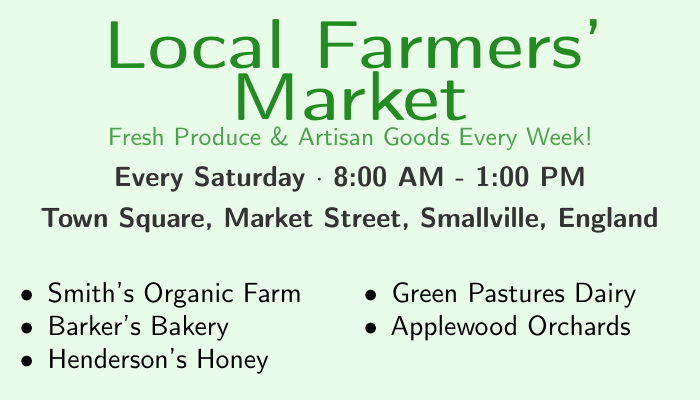What day is the farmers' market held? The document states that the farmers' market occurs every Saturday.
Answer: Saturday What are the opening hours of the market? The market operates from 8:00 AM to 1:00 PM.
Answer: 8:00 AM - 1:00 PM Where is the farmers' market located? The document specifies the location as Town Square, Market Street, Smallville, England.
Answer: Town Square, Market Street, Smallville, England Which vendor sells honey? The list of vendors includes Henderson's Honey as the honey seller.
Answer: Henderson's Honey How many key vendors are listed? There are five vendors mentioned in the document.
Answer: Five What type of goods does the market feature? The document highlights fresh produce and artisan goods.
Answer: Fresh Produce & Artisan Goods What is the phone number for the market? The contact information lists the phone number as 01234 567890.
Answer: 01234 567890 What social media platforms are mentioned? The document points to Facebook and Instagram as the social media platforms.
Answer: Facebook and Instagram Is the farmers' market a weekly event? The wording in the document indicates that the market happens every week.
Answer: Yes 